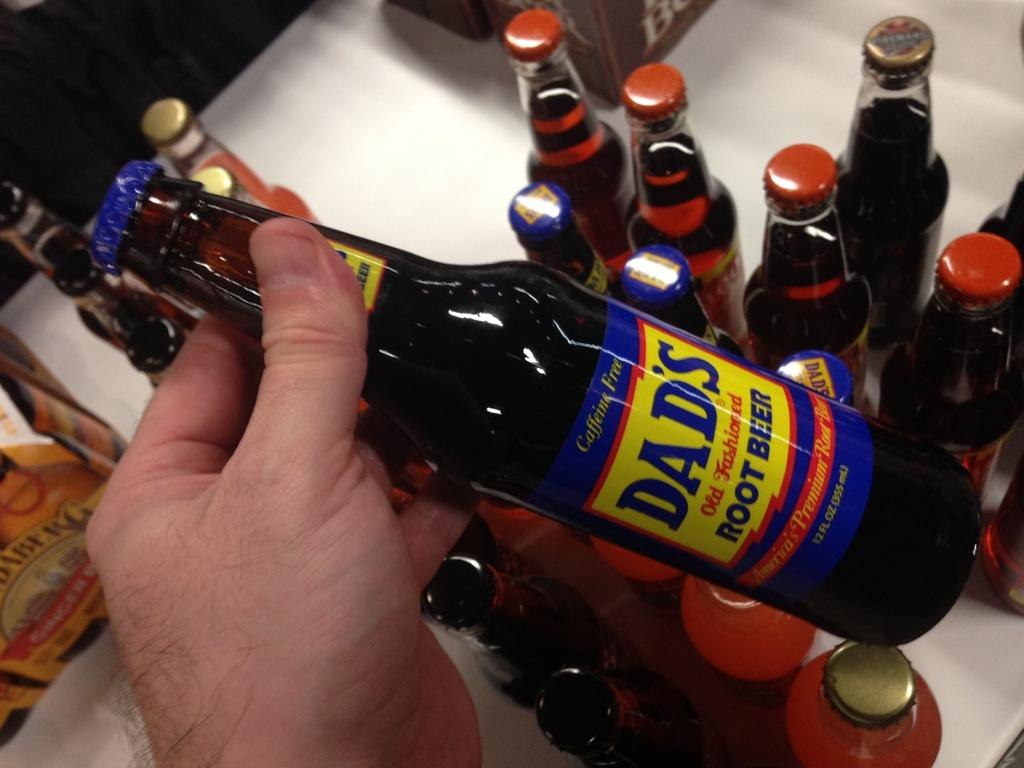<image>
Describe the image concisely. A hand holding a bottle of  Dad's root beer. 